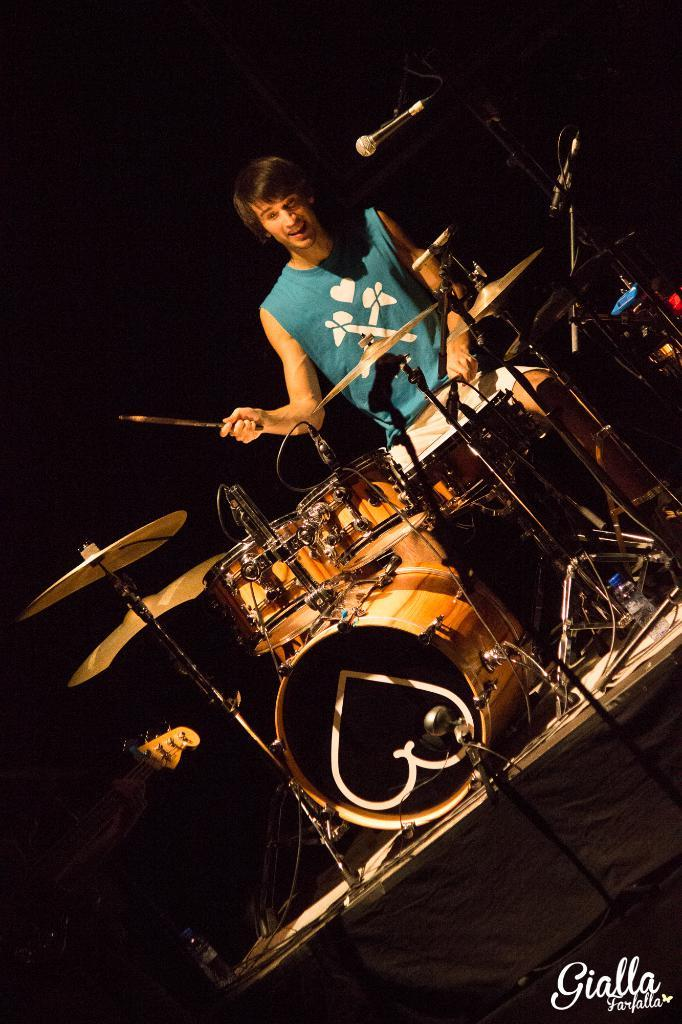Who is present in the image? There is a person in the image. What is the person wearing? The person is wearing a blue shirt. What can be seen behind the person? The person is standing in front of a musical instrument set. What is the person doing in the image? The person is playing the musical instrument. What type of advice can be seen written on the cakes in the image? There are no cakes present in the image, and therefore no advice can be seen written on them. 